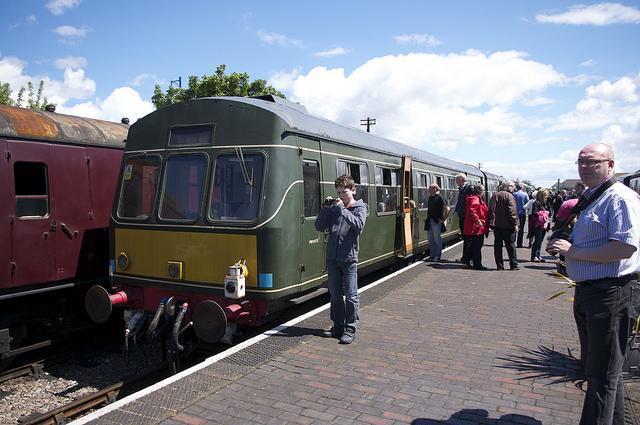How many trains can be seen?
Give a very brief answer. 2. How many people can be seen?
Give a very brief answer. 2. 